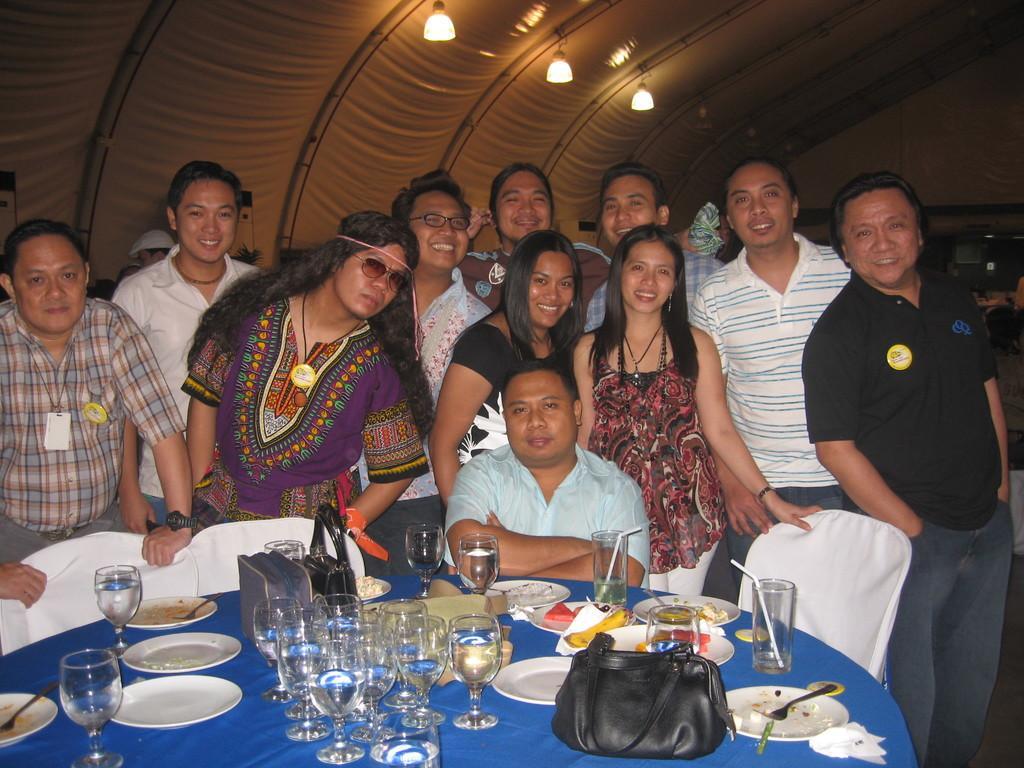Could you give a brief overview of what you see in this image? In this image we can see people. At the bottom there is a man sitting and we can see a table. There are glasses,plates, forks, bags, fruits, napkins and some food placed on the table. In the background there is a wall and lights. We can see chairs. 